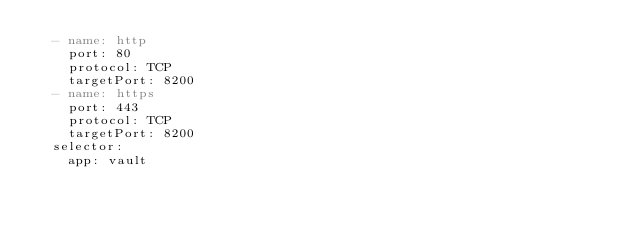<code> <loc_0><loc_0><loc_500><loc_500><_YAML_>  - name: http
    port: 80
    protocol: TCP
    targetPort: 8200
  - name: https
    port: 443
    protocol: TCP
    targetPort: 8200
  selector:
    app: vault

</code> 